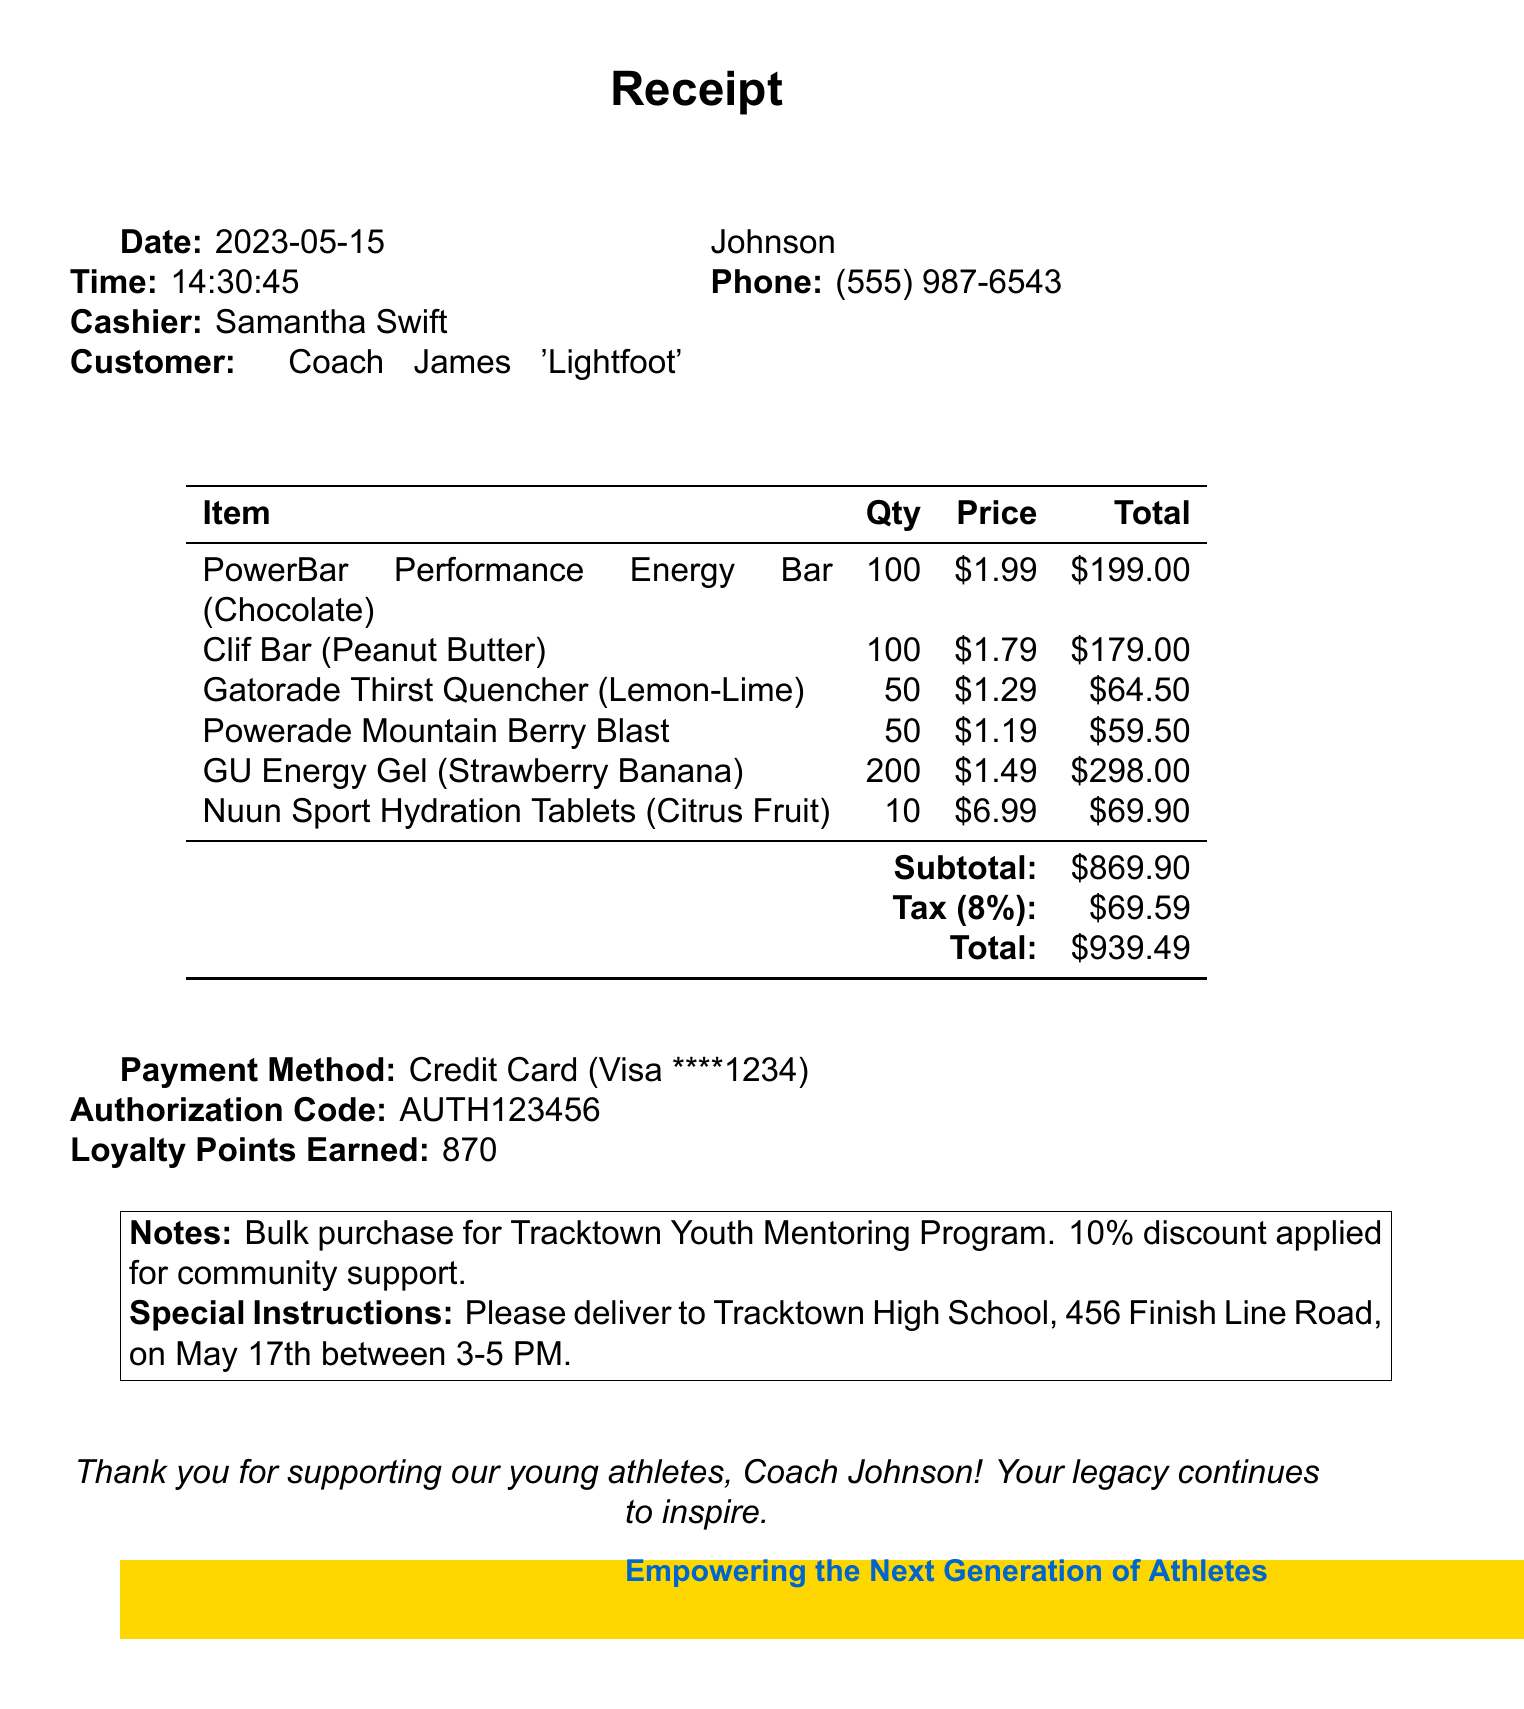What is the date of the purchase? The date of the purchase is listed at the top of the document.
Answer: 2023-05-15 Who is the cashier? The cashier's name is mentioned in the receipt details.
Answer: Samantha Swift How many Power Bars were purchased? The quantity of Power Bars is specified in the itemized list.
Answer: 100 What is the subtotal amount? The subtotal is clearly stated in the receipt near the end.
Answer: $869.90 What was the total cost after tax? The total cost is calculated and displayed at the bottom of the receipt.
Answer: $939.49 What discount was applied to the purchase? The notes section mentions a discount for the community support.
Answer: 10% How many loyalty points were earned? The loyalty points earned are indicated towards the end of the receipt.
Answer: 870 What are the special delivery instructions? The special instructions for delivery are provided in the notes section.
Answer: Please deliver to Tracktown High School, 456 Finish Line Road, on May 17th between 3-5 PM What type of payment method was used? The payment method is stated in the information section of the receipt.
Answer: Credit Card 